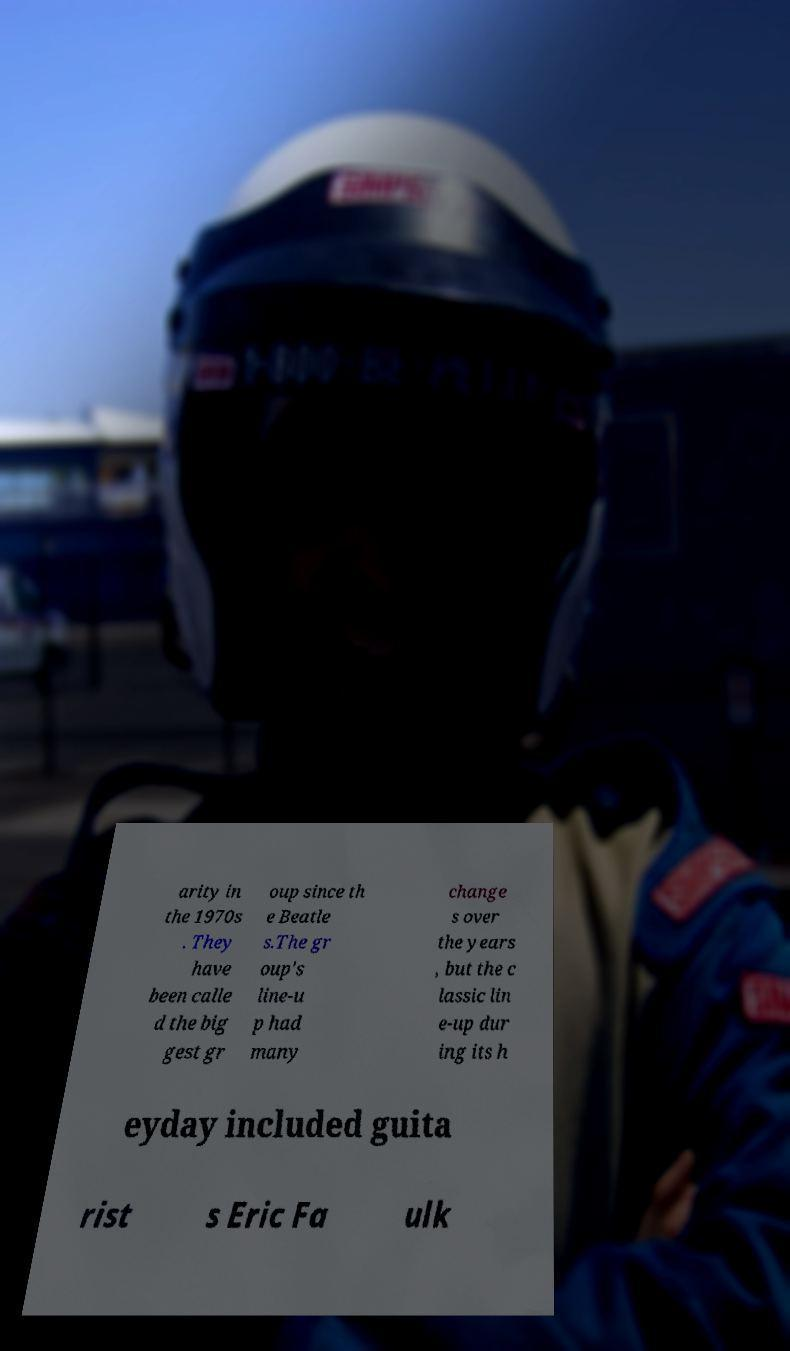Could you assist in decoding the text presented in this image and type it out clearly? arity in the 1970s . They have been calle d the big gest gr oup since th e Beatle s.The gr oup's line-u p had many change s over the years , but the c lassic lin e-up dur ing its h eyday included guita rist s Eric Fa ulk 